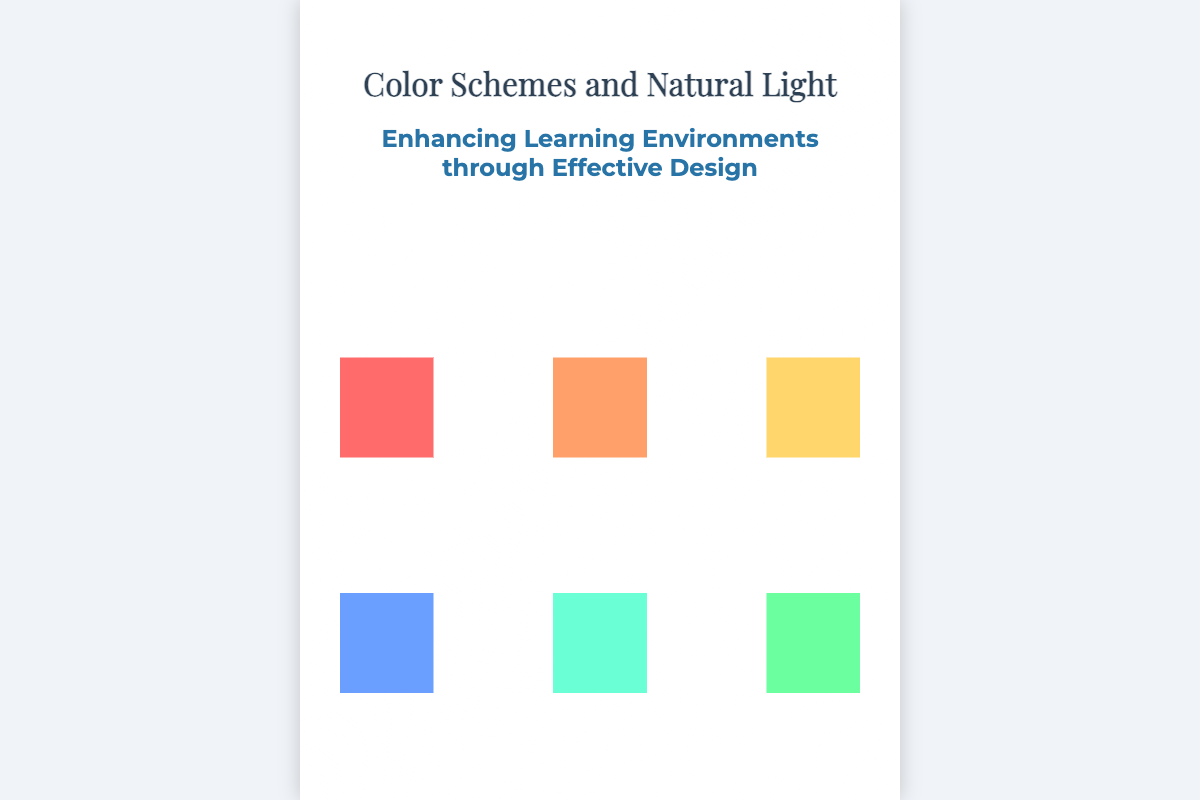what is the title of the book? The title is prominently displayed at the top of the cover.
Answer: Color Schemes and Natural Light who is the author of the book? The author's name is located at the bottom of the cover.
Answer: John Doe what is the subtitle of the book? The subtitle is presented beneath the title, indicating the book's focus.
Answer: Enhancing Learning Environments through Effective Design how many color bars are displayed on the cover? There are two sections of color bars representing different color schemes.
Answer: 6 what colors are represented in the warm colors section? The warm colors consist of reds and yellows as shown in the color bars.
Answer: Red and Yellow what visual effect is depicted behind the book title? The background features a design element that adds visual interest to the title.
Answer: Light beam animation what is the background image of the cover? The background image is described as covering the entire cover, providing context related to school design.
Answer: School design in what font is the title written? The title uses a specific serif font to enhance its aesthetic appeal.
Answer: Playfair Display what is the main theme of the book? The theme focuses on how color and light can improve learning spaces.
Answer: Effective Design 